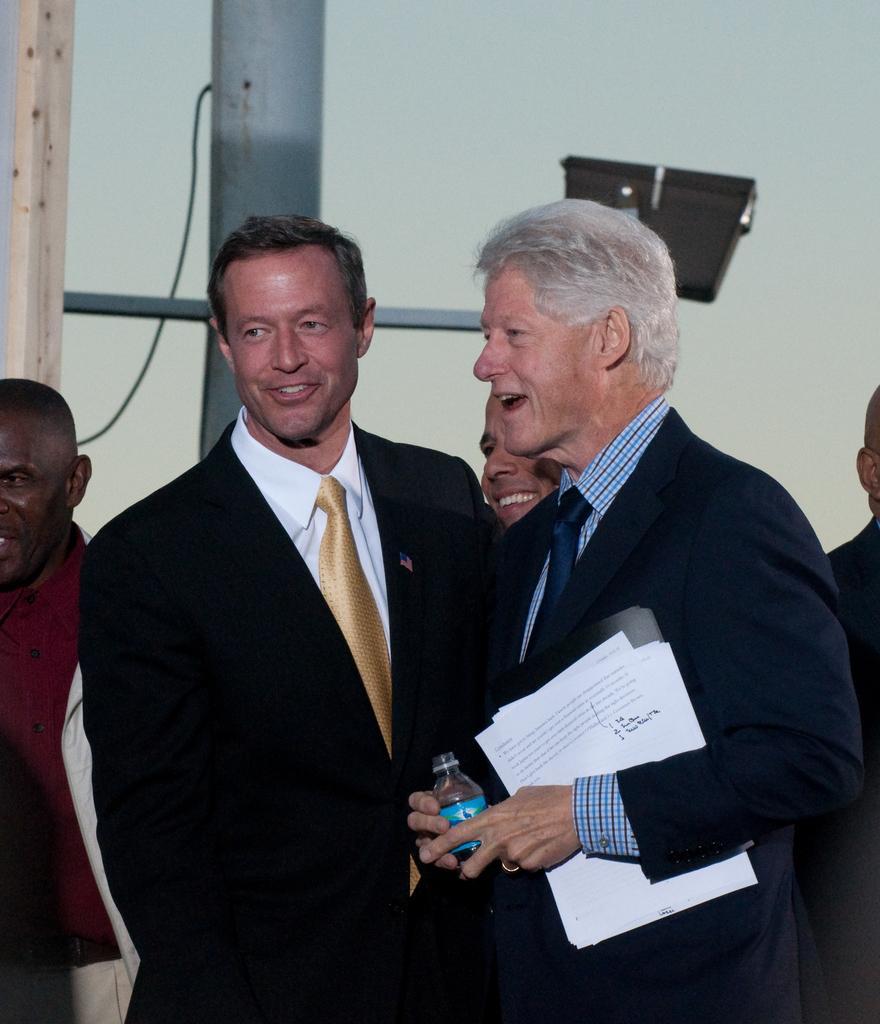In one or two sentences, can you explain what this image depicts? In this image I can see the group of people with different color dresses. I can see one person is holding the bottle and paper. In the background I can see the pole and the wall. 